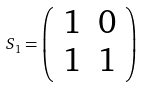Convert formula to latex. <formula><loc_0><loc_0><loc_500><loc_500>S _ { 1 } = \left ( \begin{array} { r r } 1 & 0 \\ 1 & 1 \\ \end{array} \right )</formula> 